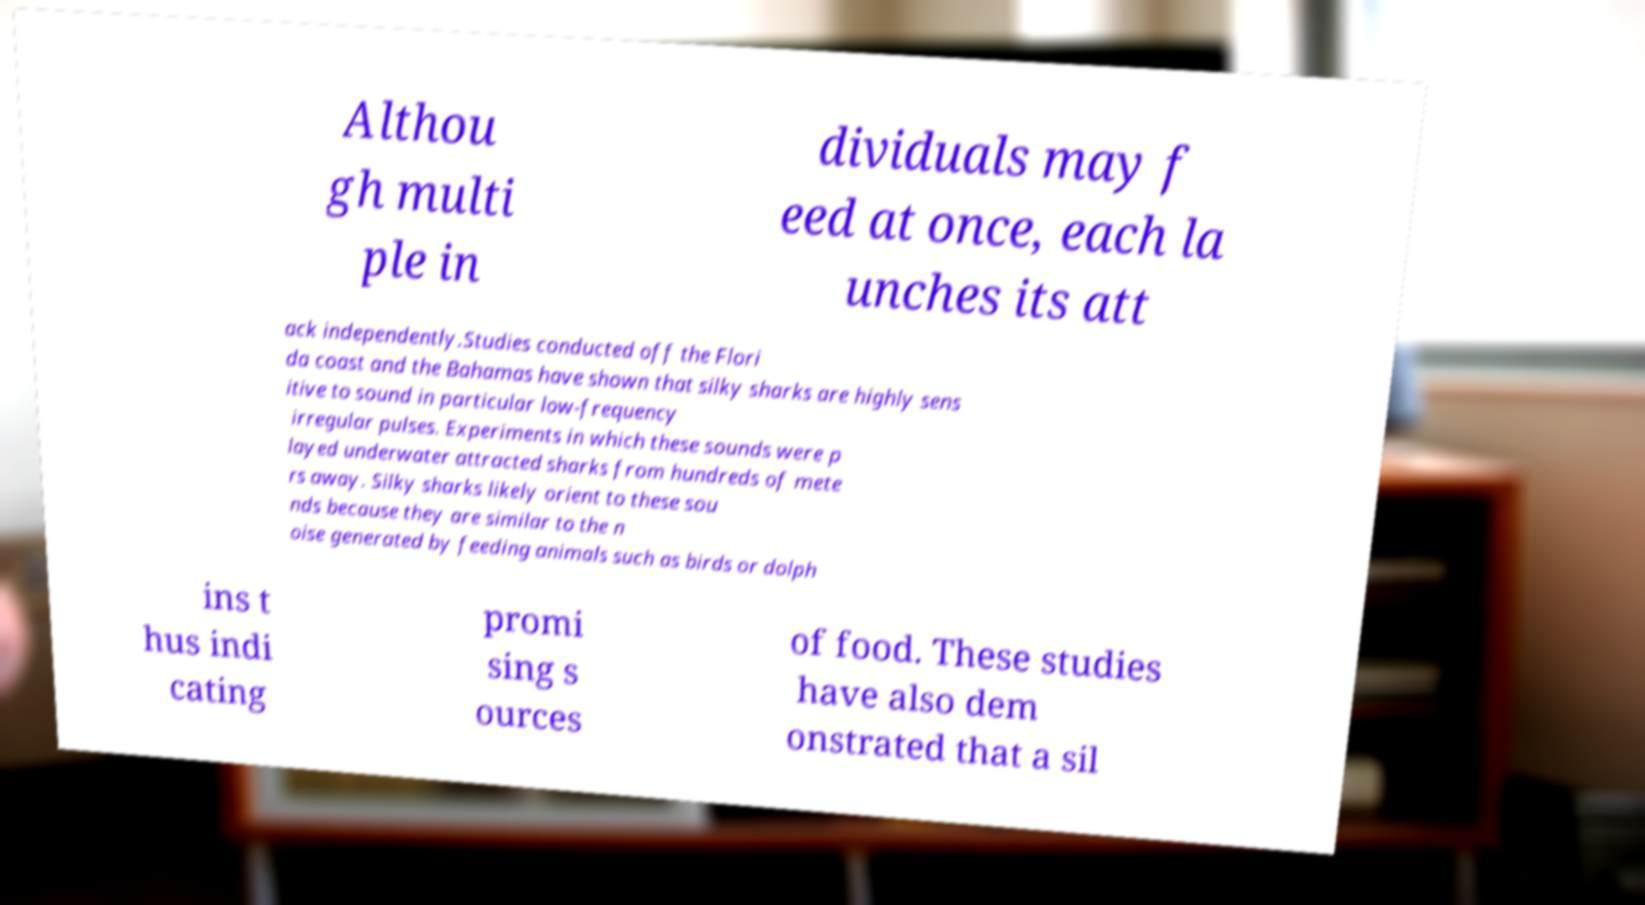Can you read and provide the text displayed in the image?This photo seems to have some interesting text. Can you extract and type it out for me? Althou gh multi ple in dividuals may f eed at once, each la unches its att ack independently.Studies conducted off the Flori da coast and the Bahamas have shown that silky sharks are highly sens itive to sound in particular low-frequency irregular pulses. Experiments in which these sounds were p layed underwater attracted sharks from hundreds of mete rs away. Silky sharks likely orient to these sou nds because they are similar to the n oise generated by feeding animals such as birds or dolph ins t hus indi cating promi sing s ources of food. These studies have also dem onstrated that a sil 